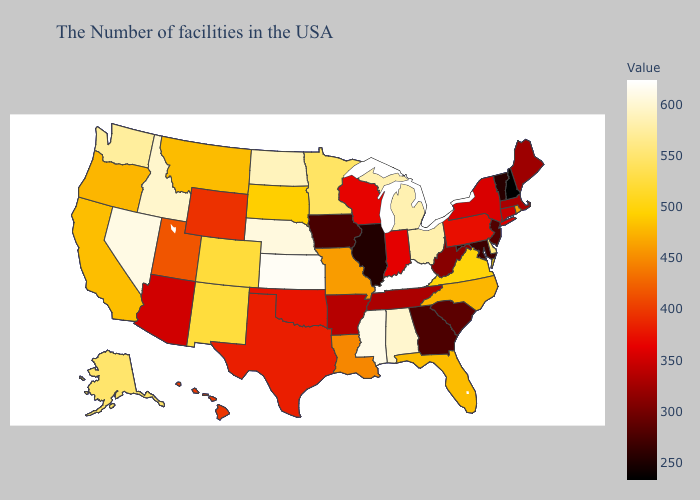Does the map have missing data?
Give a very brief answer. No. Which states have the highest value in the USA?
Keep it brief. Kentucky. Does New Jersey have a higher value than New Hampshire?
Be succinct. Yes. Does West Virginia have the highest value in the South?
Be succinct. No. Which states have the lowest value in the Northeast?
Answer briefly. New Hampshire. 